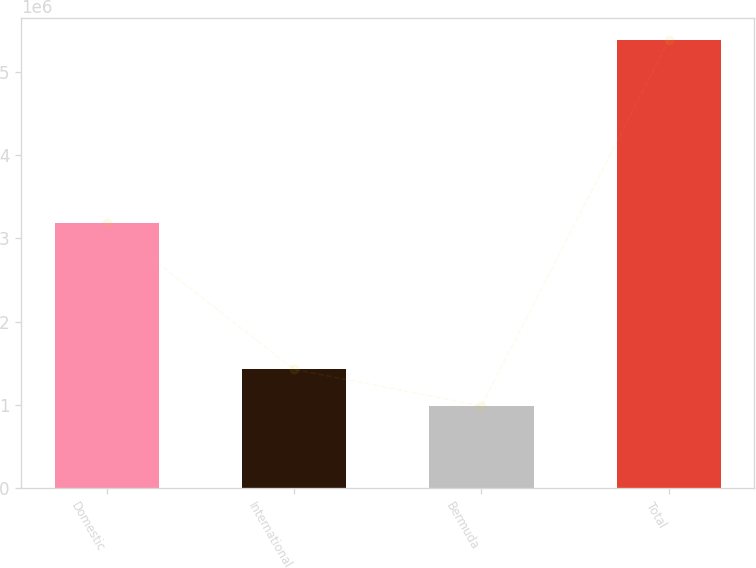Convert chart. <chart><loc_0><loc_0><loc_500><loc_500><bar_chart><fcel>Domestic<fcel>International<fcel>Bermuda<fcel>Total<nl><fcel>3.18174e+06<fcel>1.42662e+06<fcel>987544<fcel>5.37826e+06<nl></chart> 